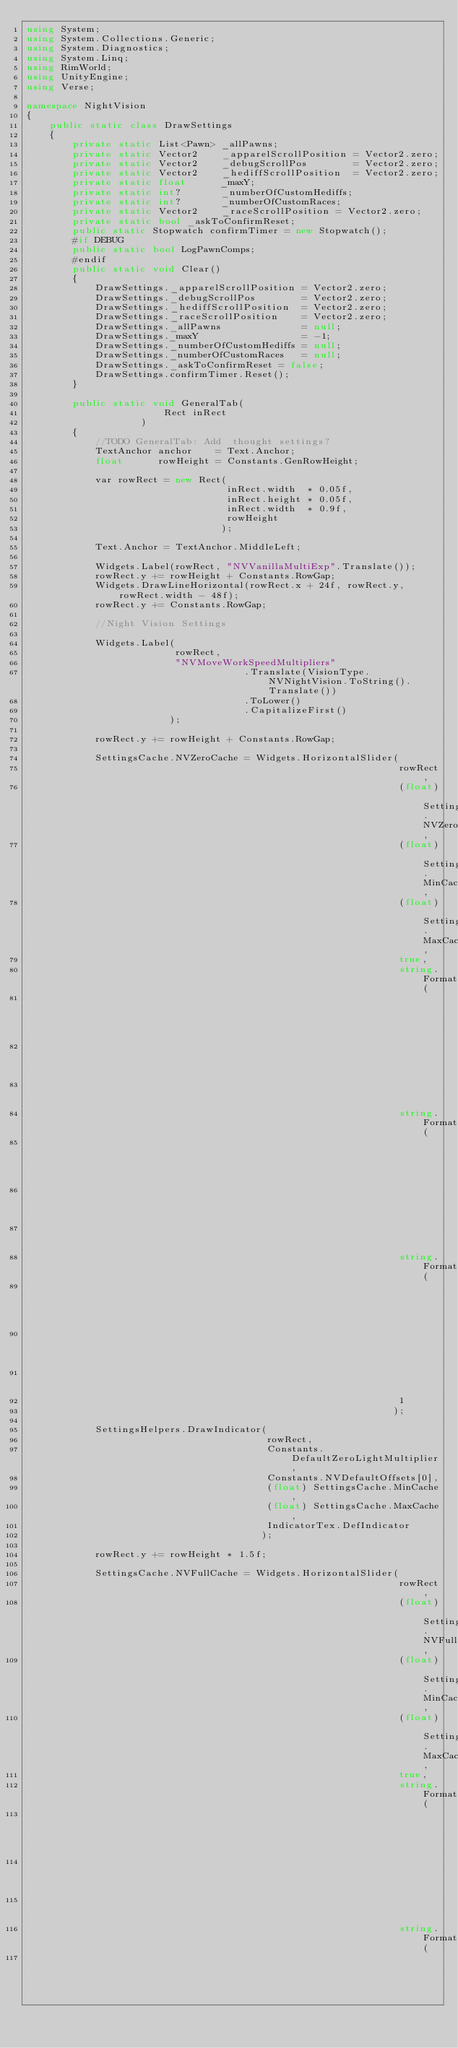<code> <loc_0><loc_0><loc_500><loc_500><_C#_>using System;
using System.Collections.Generic;
using System.Diagnostics;
using System.Linq;
using RimWorld;
using UnityEngine;
using Verse;

namespace NightVision
{
    public static class DrawSettings
    {
        private static List<Pawn> _allPawns;
        private static Vector2    _apparelScrollPosition = Vector2.zero;
        private static Vector2    _debugScrollPos        = Vector2.zero;
        private static Vector2    _hediffScrollPosition  = Vector2.zero;
        private static float      _maxY;
        private static int?       _numberOfCustomHediffs;
        private static int?       _numberOfCustomRaces;
        private static Vector2    _raceScrollPosition = Vector2.zero;
        private static bool _askToConfirmReset;
        public static Stopwatch confirmTimer = new Stopwatch();
        #if DEBUG
        public static bool LogPawnComps;
        #endif
        public static void Clear()
        {
            DrawSettings._apparelScrollPosition = Vector2.zero;
            DrawSettings._debugScrollPos        = Vector2.zero;
            DrawSettings._hediffScrollPosition  = Vector2.zero;
            DrawSettings._raceScrollPosition    = Vector2.zero;
            DrawSettings._allPawns              = null;
            DrawSettings._maxY                  = -1;
            DrawSettings._numberOfCustomHediffs = null;
            DrawSettings._numberOfCustomRaces   = null;
            DrawSettings._askToConfirmReset = false;
            DrawSettings.confirmTimer.Reset();
        }

        public static void GeneralTab(
                        Rect inRect
                    )
        {
            //TODO GeneralTab: Add  thought settings?
            TextAnchor anchor    = Text.Anchor;
            float      rowHeight = Constants.GenRowHeight;

            var rowRect = new Rect(
                                   inRect.width  * 0.05f,
                                   inRect.height * 0.05f,
                                   inRect.width  * 0.9f,
                                   rowHeight
                                  );

            Text.Anchor = TextAnchor.MiddleLeft;

            Widgets.Label(rowRect, "NVVanillaMultiExp".Translate());
            rowRect.y += rowHeight + Constants.RowGap;
            Widgets.DrawLineHorizontal(rowRect.x + 24f, rowRect.y, rowRect.width - 48f);
            rowRect.y += Constants.RowGap;

            //Night Vision Settings

            Widgets.Label(
                          rowRect,
                          "NVMoveWorkSpeedMultipliers"
                                      .Translate(VisionType.NVNightVision.ToString().Translate())
                                      .ToLower()
                                      .CapitalizeFirst()
                         );

            rowRect.y += rowHeight + Constants.RowGap;

            SettingsCache.NVZeroCache = Widgets.HorizontalSlider(
                                                                 rowRect,
                                                                 (float) SettingsCache.NVZeroCache,
                                                                 (float) SettingsCache.MinCache,
                                                                 (float) SettingsCache.MaxCache,
                                                                 true,
                                                                 string.Format(
                                                                               Constants.ZeroMultiLabel,
                                                                               SettingsCache.NVZeroCache
                                                                              ),
                                                                 string.Format(
                                                                               Constants.XLabel,
                                                                               SettingsCache.MinCache
                                                                              ),
                                                                 string.Format(
                                                                               Constants.XLabel,
                                                                               SettingsCache.MaxCache
                                                                              ),
                                                                 1
                                                                );

            SettingsHelpers.DrawIndicator(
                                          rowRect,
                                          Constants.DefaultZeroLightMultiplier,
                                          Constants.NVDefaultOffsets[0],
                                          (float) SettingsCache.MinCache,
                                          (float) SettingsCache.MaxCache,
                                          IndicatorTex.DefIndicator
                                         );

            rowRect.y += rowHeight * 1.5f;

            SettingsCache.NVFullCache = Widgets.HorizontalSlider(
                                                                 rowRect,
                                                                 (float) SettingsCache.NVFullCache,
                                                                 (float) SettingsCache.MinCache,
                                                                 (float) SettingsCache.MaxCache,
                                                                 true,
                                                                 string.Format(
                                                                               Constants.FullMultiLabel,
                                                                               SettingsCache.NVFullCache
                                                                              ),
                                                                 string.Format(
                                                                               Constants.XLabel,</code> 